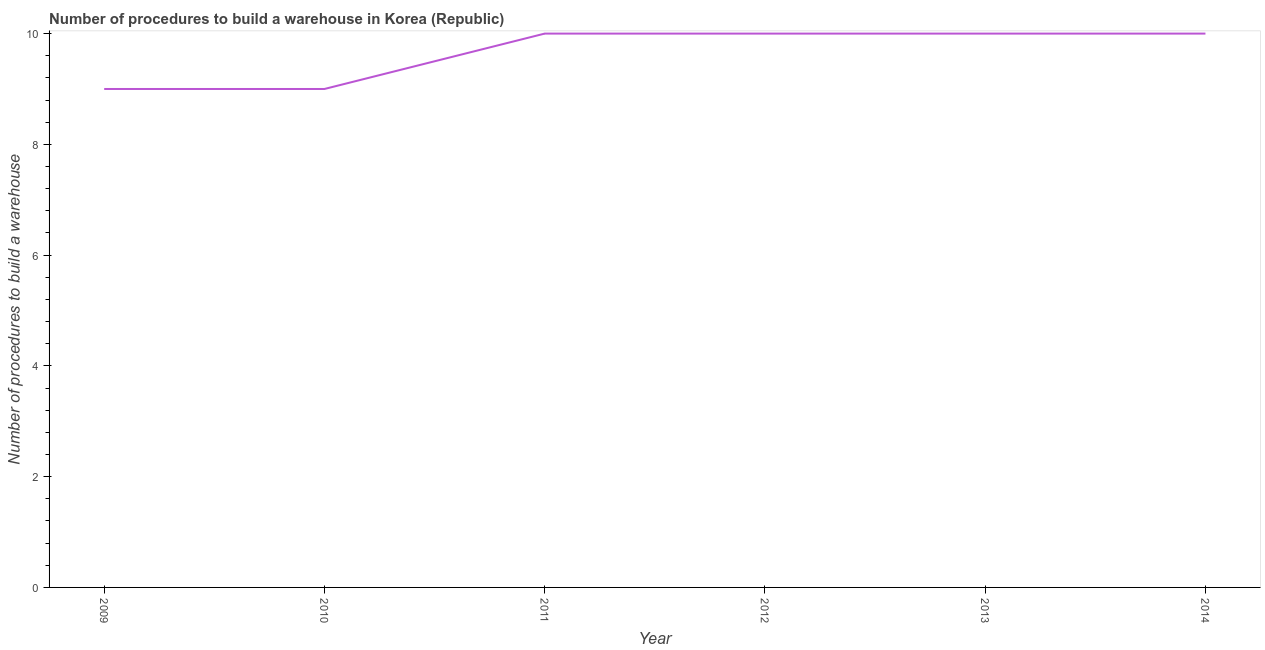What is the number of procedures to build a warehouse in 2014?
Your answer should be compact. 10. Across all years, what is the maximum number of procedures to build a warehouse?
Your response must be concise. 10. Across all years, what is the minimum number of procedures to build a warehouse?
Make the answer very short. 9. In which year was the number of procedures to build a warehouse minimum?
Keep it short and to the point. 2009. What is the sum of the number of procedures to build a warehouse?
Your answer should be very brief. 58. What is the difference between the number of procedures to build a warehouse in 2011 and 2012?
Your answer should be very brief. 0. What is the average number of procedures to build a warehouse per year?
Ensure brevity in your answer.  9.67. What is the median number of procedures to build a warehouse?
Keep it short and to the point. 10. What is the ratio of the number of procedures to build a warehouse in 2013 to that in 2014?
Your answer should be compact. 1. Is the difference between the number of procedures to build a warehouse in 2011 and 2012 greater than the difference between any two years?
Your response must be concise. No. Is the sum of the number of procedures to build a warehouse in 2009 and 2011 greater than the maximum number of procedures to build a warehouse across all years?
Your response must be concise. Yes. What is the difference between the highest and the lowest number of procedures to build a warehouse?
Your answer should be very brief. 1. In how many years, is the number of procedures to build a warehouse greater than the average number of procedures to build a warehouse taken over all years?
Ensure brevity in your answer.  4. Does the number of procedures to build a warehouse monotonically increase over the years?
Make the answer very short. No. What is the difference between two consecutive major ticks on the Y-axis?
Ensure brevity in your answer.  2. Are the values on the major ticks of Y-axis written in scientific E-notation?
Your response must be concise. No. Does the graph contain any zero values?
Keep it short and to the point. No. What is the title of the graph?
Ensure brevity in your answer.  Number of procedures to build a warehouse in Korea (Republic). What is the label or title of the X-axis?
Ensure brevity in your answer.  Year. What is the label or title of the Y-axis?
Give a very brief answer. Number of procedures to build a warehouse. What is the Number of procedures to build a warehouse in 2009?
Make the answer very short. 9. What is the Number of procedures to build a warehouse in 2011?
Provide a short and direct response. 10. What is the Number of procedures to build a warehouse in 2012?
Ensure brevity in your answer.  10. What is the Number of procedures to build a warehouse of 2014?
Offer a terse response. 10. What is the difference between the Number of procedures to build a warehouse in 2009 and 2010?
Give a very brief answer. 0. What is the difference between the Number of procedures to build a warehouse in 2009 and 2011?
Give a very brief answer. -1. What is the difference between the Number of procedures to build a warehouse in 2009 and 2012?
Ensure brevity in your answer.  -1. What is the difference between the Number of procedures to build a warehouse in 2010 and 2011?
Offer a terse response. -1. What is the difference between the Number of procedures to build a warehouse in 2010 and 2014?
Provide a succinct answer. -1. What is the difference between the Number of procedures to build a warehouse in 2011 and 2012?
Give a very brief answer. 0. What is the difference between the Number of procedures to build a warehouse in 2011 and 2014?
Keep it short and to the point. 0. What is the difference between the Number of procedures to build a warehouse in 2012 and 2014?
Keep it short and to the point. 0. What is the ratio of the Number of procedures to build a warehouse in 2009 to that in 2012?
Your response must be concise. 0.9. What is the ratio of the Number of procedures to build a warehouse in 2009 to that in 2013?
Your answer should be very brief. 0.9. What is the ratio of the Number of procedures to build a warehouse in 2010 to that in 2011?
Provide a short and direct response. 0.9. What is the ratio of the Number of procedures to build a warehouse in 2010 to that in 2013?
Provide a short and direct response. 0.9. What is the ratio of the Number of procedures to build a warehouse in 2010 to that in 2014?
Provide a succinct answer. 0.9. What is the ratio of the Number of procedures to build a warehouse in 2011 to that in 2012?
Keep it short and to the point. 1. What is the ratio of the Number of procedures to build a warehouse in 2012 to that in 2013?
Provide a short and direct response. 1. What is the ratio of the Number of procedures to build a warehouse in 2012 to that in 2014?
Your answer should be compact. 1. What is the ratio of the Number of procedures to build a warehouse in 2013 to that in 2014?
Provide a succinct answer. 1. 